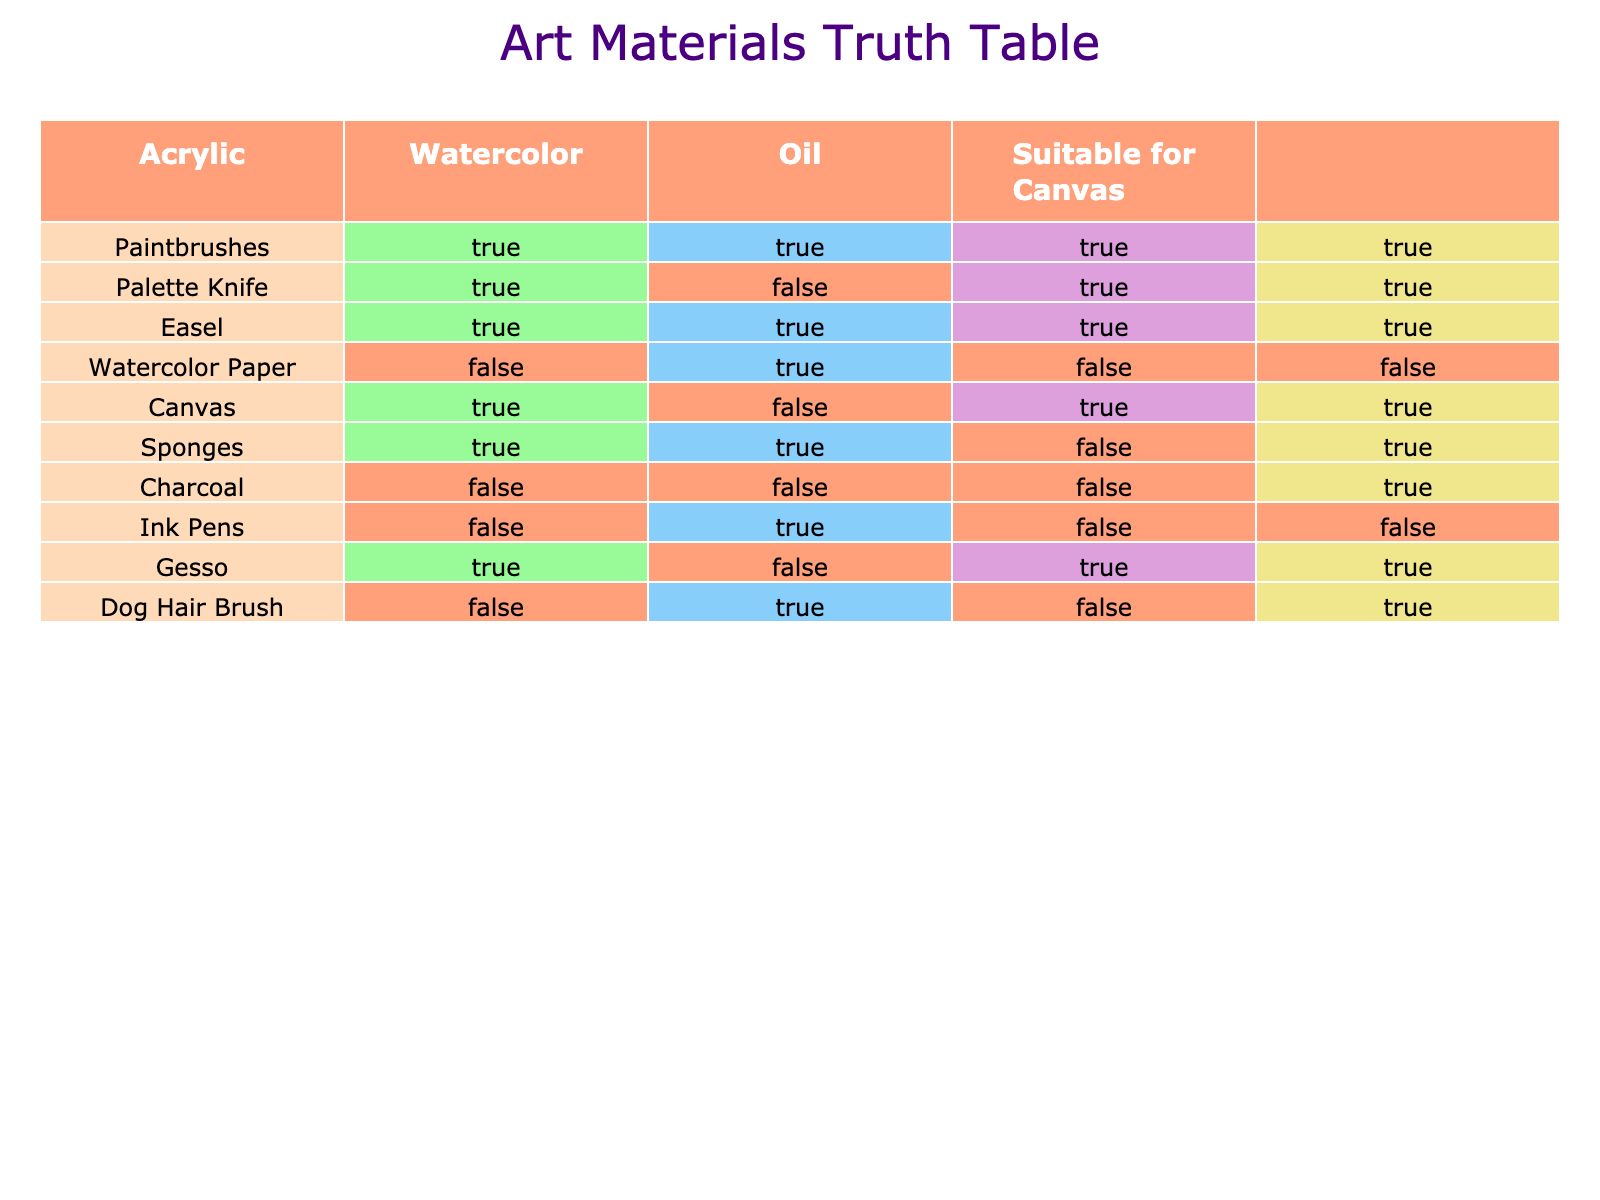What materials can be used for oil painting? By looking at the "Oil" column in the table, we can identify which materials are suitable for oil painting. The materials that have "TRUE" listed in the Oil column are Paintbrushes, Palette Knife, Easel, Canvas, and Gesso.
Answer: Paintbrushes, Palette Knife, Easel, Canvas, Gesso Can watercolor paper be used for acrylic painting? Checking the "Acrylic" column for the material "Watercolor Paper", we see that it is marked as "FALSE", which indicates that watercolor paper is not suitable for acrylic painting.
Answer: No How many materials are suitable for canvas? To find the total number of materials that are suitable for canvas, we can count the number of "TRUE" values in the "Suitable for Canvas" column. The materials that are marked as "TRUE" are Paintbrushes, Palette Knife, Easel, Canvas, Sponges, Charcoal, and Dog Hair Brush, which is 6 in total.
Answer: 6 Is a palette knife suitable for watercolor? Assessing the "Watercolor" column for the material "Palette Knife", we find a "FALSE" value, meaning that a palette knife is not suitable for watercolor painting.
Answer: No Which materials are suitable for watercolor painting but not for canvas? We need to look for materials that are marked "TRUE" in the Watercolor column and "FALSE" in the "Suitable for Canvas" column. The only material that meets this criterion is Ink Pens.
Answer: Ink Pens What percentage of materials can be used for acrylic painting? First, we count the total number of materials listed, which is 10. Next, we count the number of materials that are suitable for acrylic painting, which are Paintbrushes, Palette Knife, Easel, Canvas, and Sponges, totaling 5. The percentage calculation is (5/10) * 100 = 50%.
Answer: 50% Which unique material can be used for watercolor and canvas but not for acrylic or oil? We examine the Watercolor and Canvas columns for materials marked as "TRUE" and then check the values for acrylic and oil. The only material that is "TRUE" for Watercolor and "TRUE" for Suitable for Canvas, while being "FALSE" for Acrylic and Oil is "Dog Hair Brush".
Answer: Dog Hair Brush Are paintbrushes suitable for all types of painting listed? We verify the values in the Acrylic, Watercolor, and Oil columns for the material "Paintbrushes". Since all of these are marked as "TRUE", paintbrushes are indeed suitable for all types of painting listed in the table.
Answer: Yes 